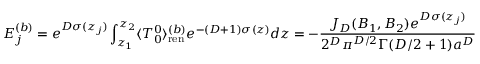<formula> <loc_0><loc_0><loc_500><loc_500>E _ { j } ^ { ( b ) } = e ^ { D \sigma ( z _ { j } ) } \int _ { z _ { 1 } } ^ { z _ { 2 } } \langle T _ { 0 } ^ { 0 } \rangle _ { r e n } ^ { ( b ) } e ^ { - ( D + 1 ) \sigma ( z ) } d z = - \frac { J _ { D } ( B _ { 1 } , B _ { 2 } ) e ^ { D \sigma ( z _ { j } ) } } { 2 ^ { D } \pi ^ { D / 2 } \Gamma ( D / 2 + 1 ) a ^ { D } } .</formula> 